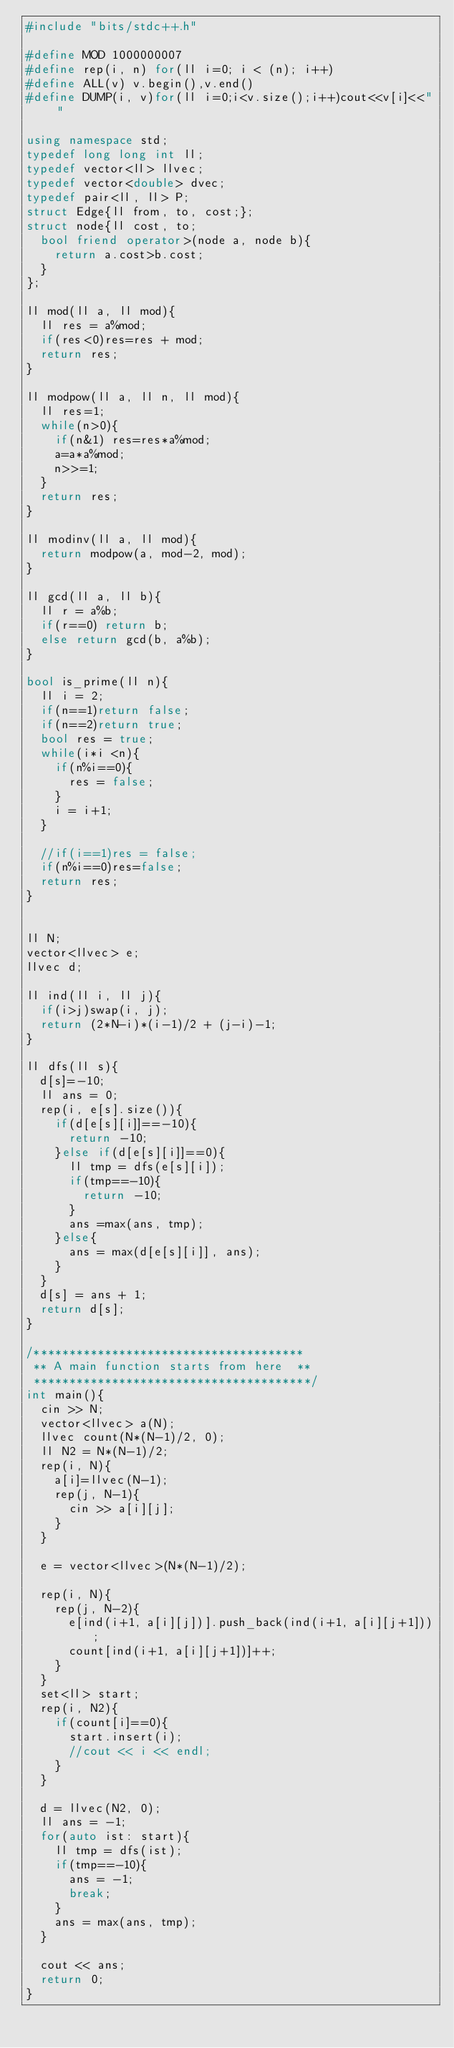Convert code to text. <code><loc_0><loc_0><loc_500><loc_500><_C++_>#include "bits/stdc++.h"

#define MOD 1000000007
#define rep(i, n) for(ll i=0; i < (n); i++)
#define ALL(v) v.begin(),v.end()
#define DUMP(i, v)for(ll i=0;i<v.size();i++)cout<<v[i]<<" "

using namespace std;
typedef long long int ll;
typedef vector<ll> llvec;
typedef vector<double> dvec;
typedef pair<ll, ll> P;
struct Edge{ll from, to, cost;};
struct node{ll cost, to;
  bool friend operator>(node a, node b){
    return a.cost>b.cost;
  }
};

ll mod(ll a, ll mod){
  ll res = a%mod;
  if(res<0)res=res + mod;
  return res;
}

ll modpow(ll a, ll n, ll mod){
  ll res=1;
  while(n>0){
    if(n&1) res=res*a%mod;
    a=a*a%mod;
    n>>=1;
  }
  return res;
}

ll modinv(ll a, ll mod){
  return modpow(a, mod-2, mod);
}

ll gcd(ll a, ll b){
  ll r = a%b;
  if(r==0) return b;
  else return gcd(b, a%b);
}

bool is_prime(ll n){
  ll i = 2;
  if(n==1)return false;
  if(n==2)return true;
  bool res = true;
  while(i*i <n){
    if(n%i==0){
      res = false;
    }
    i = i+1;
  }

  //if(i==1)res = false;
  if(n%i==0)res=false;
  return res;
}


ll N;
vector<llvec> e;
llvec d;

ll ind(ll i, ll j){
  if(i>j)swap(i, j);
  return (2*N-i)*(i-1)/2 + (j-i)-1;
}

ll dfs(ll s){
  d[s]=-10;
  ll ans = 0;
  rep(i, e[s].size()){
    if(d[e[s][i]]==-10){
      return -10;
    }else if(d[e[s][i]]==0){
      ll tmp = dfs(e[s][i]);
      if(tmp==-10){
        return -10;
      }
      ans =max(ans, tmp);
    }else{
      ans = max(d[e[s][i]], ans);
    }
  }
  d[s] = ans + 1;
  return d[s];
}

/**************************************
 ** A main function starts from here  **
 ***************************************/
int main(){
  cin >> N;
  vector<llvec> a(N);
  llvec count(N*(N-1)/2, 0);
  ll N2 = N*(N-1)/2;
  rep(i, N){
    a[i]=llvec(N-1);
    rep(j, N-1){
      cin >> a[i][j];
    }
  }

  e = vector<llvec>(N*(N-1)/2);
  
  rep(i, N){
    rep(j, N-2){
      e[ind(i+1, a[i][j])].push_back(ind(i+1, a[i][j+1]));
      count[ind(i+1, a[i][j+1])]++;
    }
  }
  set<ll> start;
  rep(i, N2){
    if(count[i]==0){
      start.insert(i);
      //cout << i << endl;
    }
  }

  d = llvec(N2, 0);
  ll ans = -1;
  for(auto ist: start){
    ll tmp = dfs(ist);
    if(tmp==-10){
      ans = -1;
      break;
    }
    ans = max(ans, tmp);
  }

  cout << ans;
  return 0;
}
</code> 